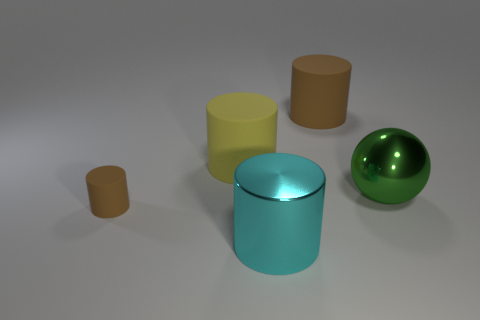What materials do the objects in this picture appear to be made of? The objects in the image appear to be made from various materials: the two cylinders on the left and the smaller cylinder in front appear to be made of a matte material, perhaps something similar to clay or plastic. The larger, central cylinder has a reflective surface, suggesting it could be metallic, and the sphere has a glossy finish, likely indicative of a polished metal or a smooth plastic. 